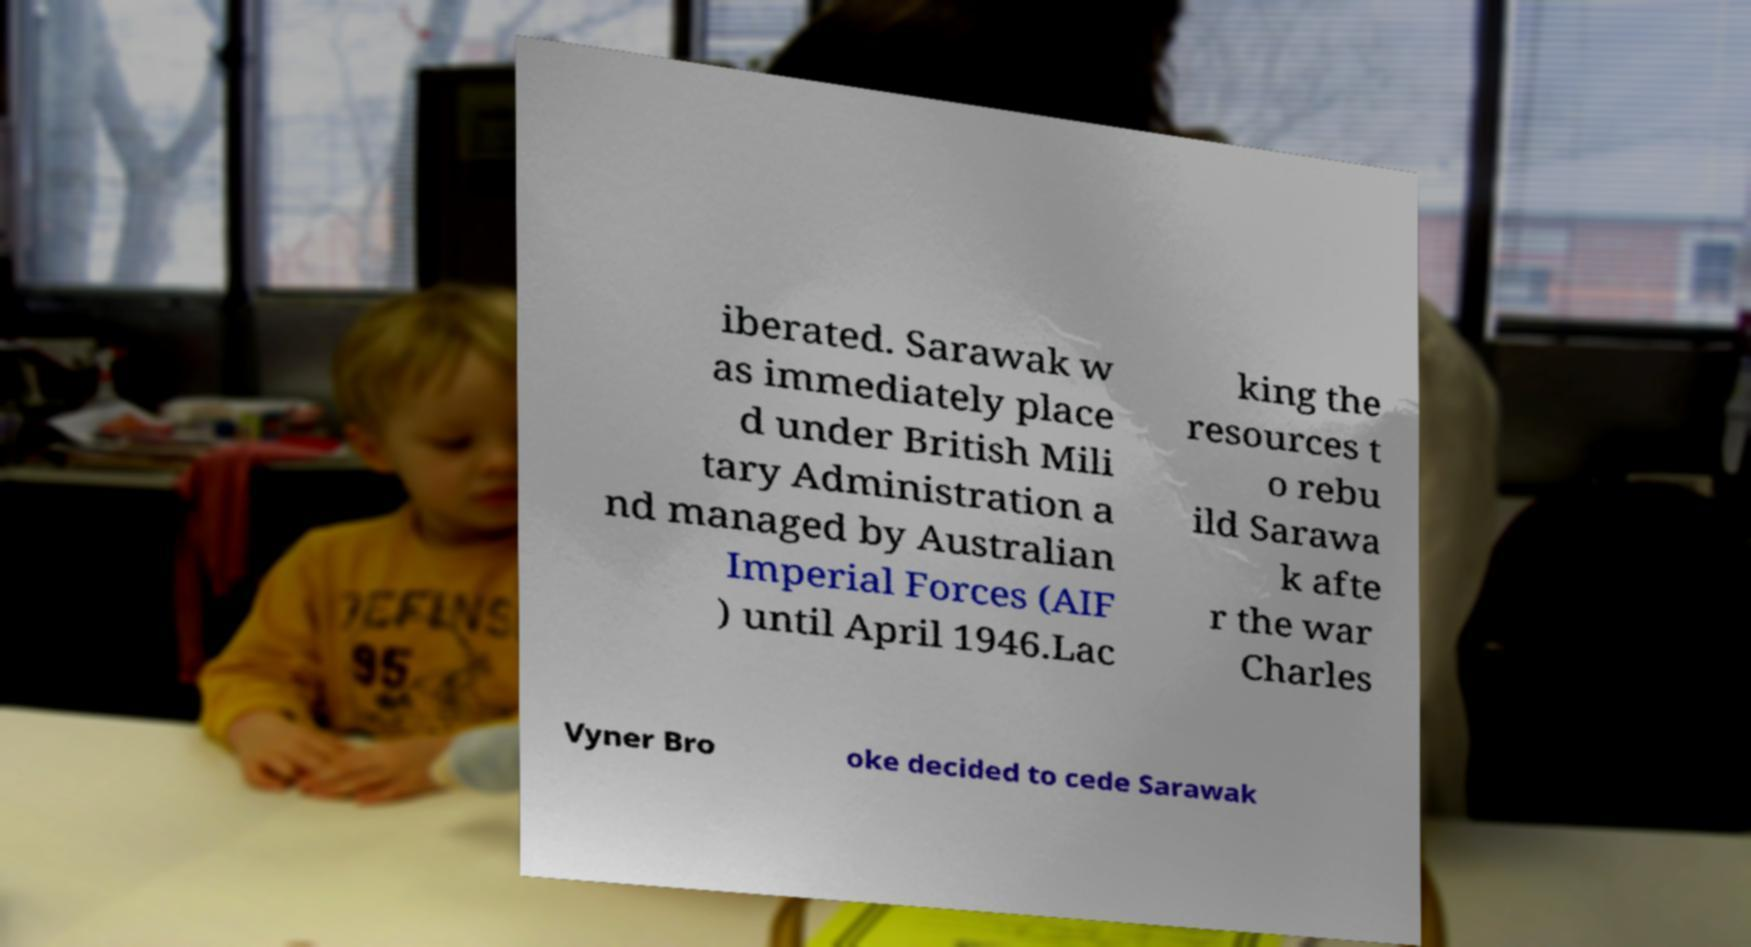Could you assist in decoding the text presented in this image and type it out clearly? iberated. Sarawak w as immediately place d under British Mili tary Administration a nd managed by Australian Imperial Forces (AIF ) until April 1946.Lac king the resources t o rebu ild Sarawa k afte r the war Charles Vyner Bro oke decided to cede Sarawak 